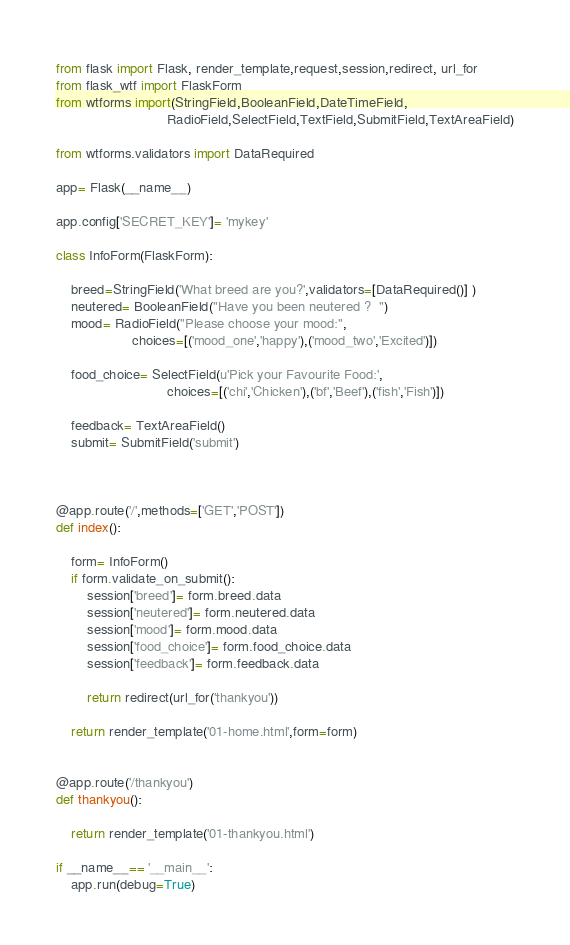Convert code to text. <code><loc_0><loc_0><loc_500><loc_500><_Python_>from flask import Flask, render_template,request,session,redirect, url_for
from flask_wtf import FlaskForm
from wtforms import(StringField,BooleanField,DateTimeField,
                             RadioField,SelectField,TextField,SubmitField,TextAreaField)

from wtforms.validators import DataRequired

app= Flask(__name__)

app.config['SECRET_KEY']= 'mykey'

class InfoForm(FlaskForm):

    breed=StringField('What breed are you?',validators=[DataRequired()] )
    neutered= BooleanField("Have you been neutered ?  ")
    mood= RadioField("Please choose your mood:",
                    choices=[('mood_one','happy'),('mood_two','Excited')])

    food_choice= SelectField(u'Pick your Favourite Food:',
                             choices=[('chi','Chicken'),('bf','Beef'),('fish','Fish')])

    feedback= TextAreaField()
    submit= SubmitField('submit')



@app.route('/',methods=['GET','POST'])
def index():

    form= InfoForm()
    if form.validate_on_submit():
        session['breed']= form.breed.data
        session['neutered']= form.neutered.data
        session['mood']= form.mood.data
        session['food_choice']= form.food_choice.data
        session['feedback']= form.feedback.data

        return redirect(url_for('thankyou'))
    
    return render_template('01-home.html',form=form)


@app.route('/thankyou')
def thankyou():

    return render_template('01-thankyou.html')

if __name__== '__main__':
    app.run(debug=True)

</code> 